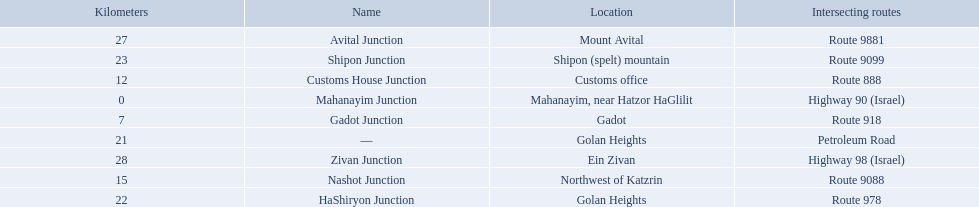Which junctions cross a route? Gadot Junction, Customs House Junction, Nashot Junction, HaShiryon Junction, Shipon Junction, Avital Junction. Which of these shares [art of its name with its locations name? Gadot Junction, Customs House Junction, Shipon Junction, Avital Junction. Which of them is not located in a locations named after a mountain? Gadot Junction, Customs House Junction. Parse the full table. {'header': ['Kilometers', 'Name', 'Location', 'Intersecting routes'], 'rows': [['27', 'Avital Junction', 'Mount Avital', 'Route 9881'], ['23', 'Shipon Junction', 'Shipon (spelt) mountain', 'Route 9099'], ['12', 'Customs House Junction', 'Customs office', 'Route 888'], ['0', 'Mahanayim Junction', 'Mahanayim, near Hatzor HaGlilit', 'Highway 90 (Israel)'], ['7', 'Gadot Junction', 'Gadot', 'Route 918'], ['21', '—', 'Golan Heights', 'Petroleum Road'], ['28', 'Zivan Junction', 'Ein Zivan', 'Highway 98 (Israel)'], ['15', 'Nashot Junction', 'Northwest of Katzrin', 'Route 9088'], ['22', 'HaShiryon Junction', 'Golan Heights', 'Route 978']]} Which of these has the highest route number? Gadot Junction. How many kilometers away is shipon junction? 23. How many kilometers away is avital junction? 27. Which one is closer to nashot junction? Shipon Junction. What are all the are all the locations on the highway 91 (israel)? Mahanayim, near Hatzor HaGlilit, Gadot, Customs office, Northwest of Katzrin, Golan Heights, Golan Heights, Shipon (spelt) mountain, Mount Avital, Ein Zivan. What are the distance values in kilometers for ein zivan, gadot junction and shipon junction? 7, 23, 28. Which is the least distance away? 7. What is the name? Gadot Junction. 